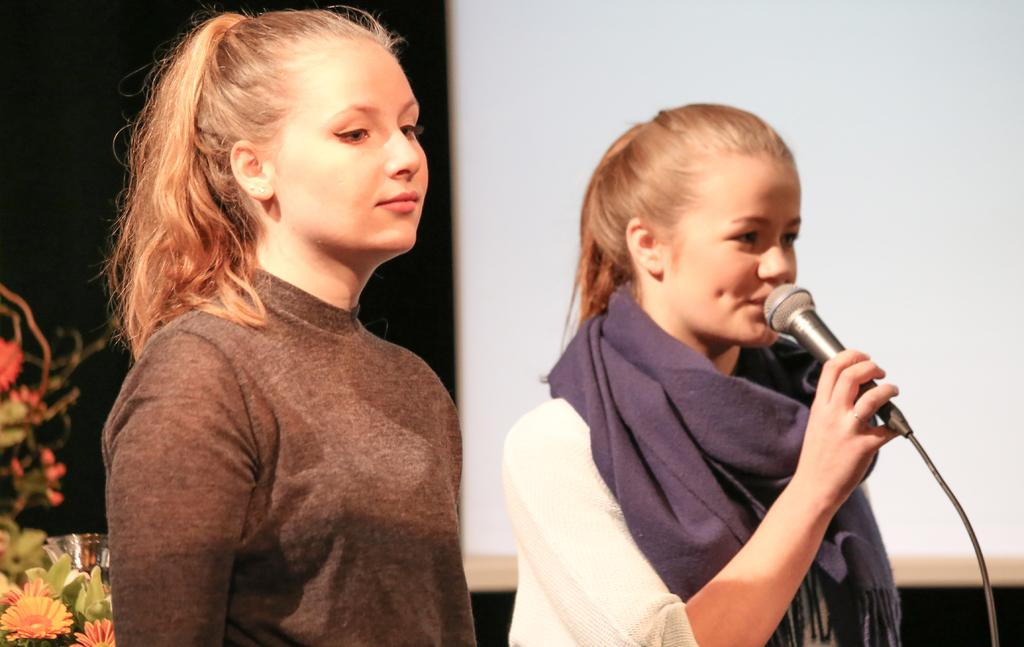How many ladies are in the image? There are two ladies in the image. What are the ladies wearing? One lady is wearing a white dress and holding a mic, while the other lady is wearing a brown color dress. What can be seen in the background of the image? There are flowers visible in the background of the image. What type of van can be seen in the image? There is no van present in the image. How many forks are visible in the image? There are no forks visible in the image. 